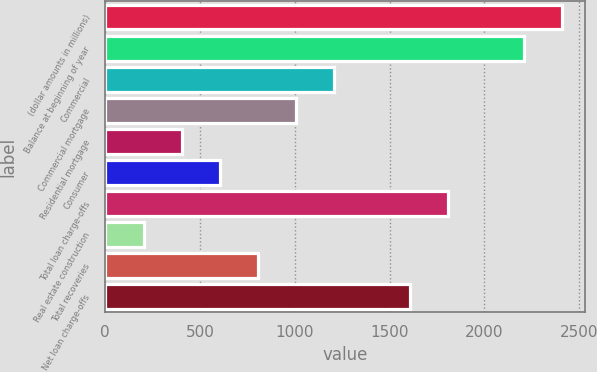Convert chart. <chart><loc_0><loc_0><loc_500><loc_500><bar_chart><fcel>(dollar amounts in millions)<fcel>Balance at beginning of year<fcel>Commercial<fcel>Commercial mortgage<fcel>Residential mortgage<fcel>Consumer<fcel>Total loan charge-offs<fcel>Real estate construction<fcel>Total recoveries<fcel>Net loan charge-offs<nl><fcel>2411.71<fcel>2210.85<fcel>1206.55<fcel>1005.69<fcel>403.11<fcel>603.97<fcel>1809.13<fcel>202.25<fcel>804.83<fcel>1608.27<nl></chart> 